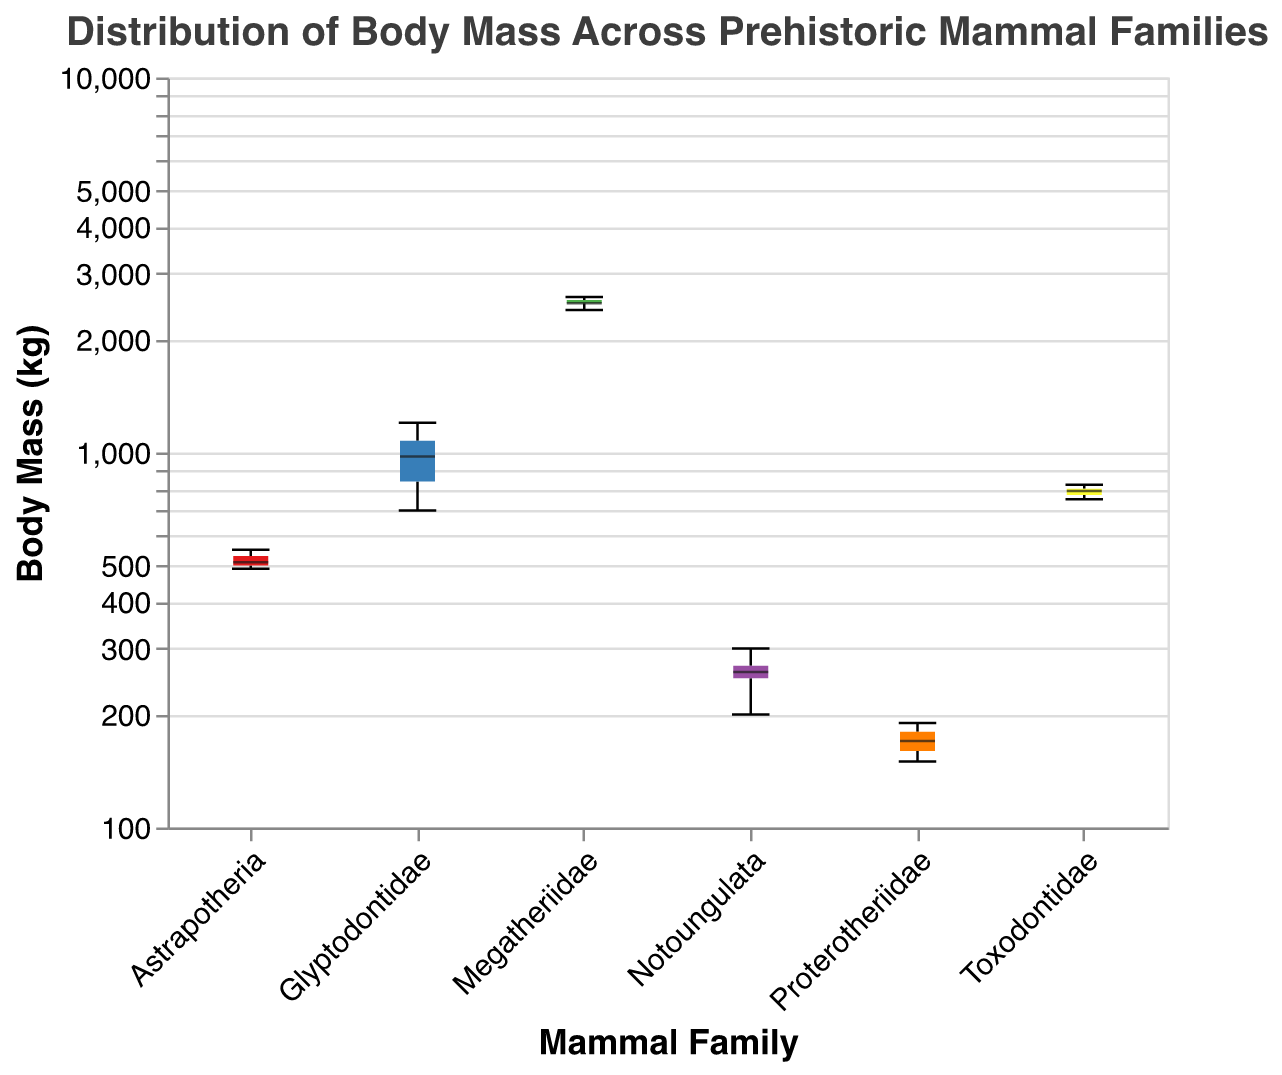What is the title of the box plot? The title of the box plot is displayed at the top of the figure.
Answer: Distribution of Body Mass Across Prehistoric Mammal Families What are the units of the y-axis? The units are displayed on the y-axis label.
Answer: kg Which mammal family has the largest median body mass? The median is represented by a bold line inside the box of each family. To find the largest, compare the heights of these lines.
Answer: Megatheriidae What is the approximate range of body mass for the family Astrapotheria? The range is represented by the minimum and maximum points of the whiskers for Astrapotheria. Estimate the values from the y-axis.
Answer: 490-550 kg How does the body mass of Proterotheriidae compare to Toxodontidae? Compare the ranges and medians of Proterotheriidae and Toxodontidae by looking at their corresponding box plots.
Answer: Proterotheriidae has a lower body mass range (150-190 kg) than Toxodontidae (750-820 kg) Which family has the smallest variation in body mass? Smallest variation is indicated by the smallest interquartile range (box height).
Answer: Notoungulata What can you infer about the body mass distribution of Glyptodontidae? Check the range, median, and interquartile range of Glyptodontidae to derive insights.
Answer: The body masses of Glyptodontidae are quite spread out, ranging from 700 to 1200 kg with a median close to 1000 kg If we use the median body mass values, how much heavier is Megatheriidae compared to Glyptodontidae? Extract the median body mass values for Megatheriidae and Glyptodontidae and calculate the difference between them.
Answer: 1550 kg (2550 - 1000) Which family shows the highest upper quartile? The highest point of the upper box edge represents the upper quartile for each family.
Answer: Megatheriidae Apart from Megatheriidae, which family has the highest body mass spread? Identify the second largest range by observing the heights of the whiskers after Megatheriidae.
Answer: Glyptodontidae 